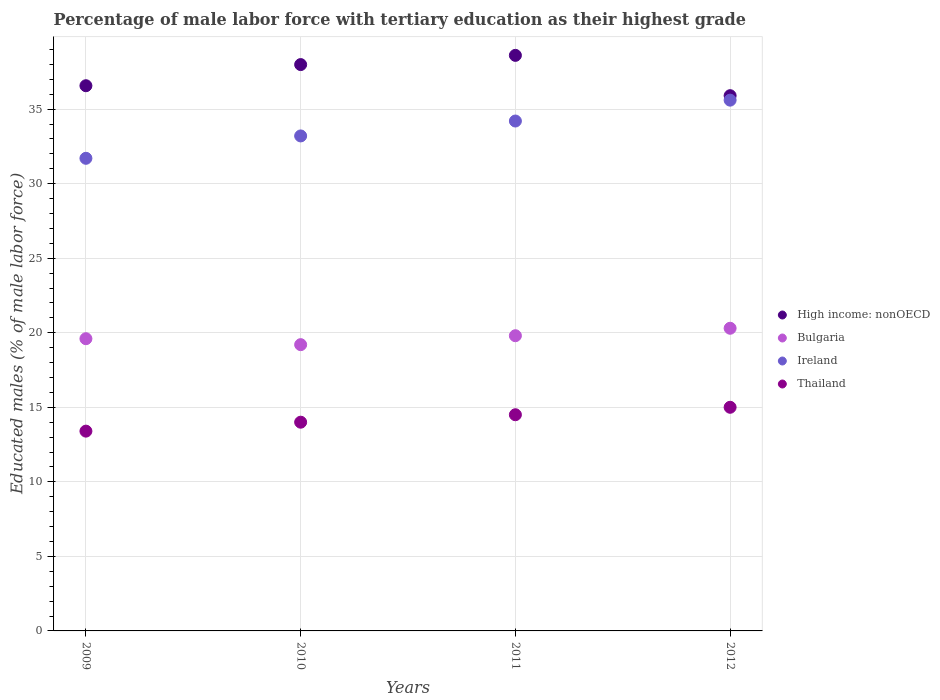How many different coloured dotlines are there?
Provide a short and direct response. 4. What is the percentage of male labor force with tertiary education in High income: nonOECD in 2011?
Make the answer very short. 38.6. Across all years, what is the minimum percentage of male labor force with tertiary education in Thailand?
Your answer should be very brief. 13.4. In which year was the percentage of male labor force with tertiary education in Bulgaria maximum?
Make the answer very short. 2012. What is the total percentage of male labor force with tertiary education in High income: nonOECD in the graph?
Your answer should be very brief. 149.06. What is the difference between the percentage of male labor force with tertiary education in Thailand in 2011 and that in 2012?
Keep it short and to the point. -0.5. What is the difference between the percentage of male labor force with tertiary education in Bulgaria in 2011 and the percentage of male labor force with tertiary education in Ireland in 2010?
Offer a terse response. -13.4. What is the average percentage of male labor force with tertiary education in Thailand per year?
Your answer should be very brief. 14.22. In the year 2009, what is the difference between the percentage of male labor force with tertiary education in High income: nonOECD and percentage of male labor force with tertiary education in Ireland?
Offer a terse response. 4.87. What is the ratio of the percentage of male labor force with tertiary education in Thailand in 2009 to that in 2011?
Provide a succinct answer. 0.92. What is the difference between the highest and the second highest percentage of male labor force with tertiary education in High income: nonOECD?
Offer a very short reply. 0.62. What is the difference between the highest and the lowest percentage of male labor force with tertiary education in Bulgaria?
Provide a short and direct response. 1.1. In how many years, is the percentage of male labor force with tertiary education in High income: nonOECD greater than the average percentage of male labor force with tertiary education in High income: nonOECD taken over all years?
Make the answer very short. 2. Is it the case that in every year, the sum of the percentage of male labor force with tertiary education in Bulgaria and percentage of male labor force with tertiary education in Ireland  is greater than the sum of percentage of male labor force with tertiary education in High income: nonOECD and percentage of male labor force with tertiary education in Thailand?
Provide a short and direct response. No. Is it the case that in every year, the sum of the percentage of male labor force with tertiary education in Bulgaria and percentage of male labor force with tertiary education in Ireland  is greater than the percentage of male labor force with tertiary education in High income: nonOECD?
Keep it short and to the point. Yes. Does the percentage of male labor force with tertiary education in High income: nonOECD monotonically increase over the years?
Your answer should be very brief. No. Is the percentage of male labor force with tertiary education in Thailand strictly greater than the percentage of male labor force with tertiary education in Bulgaria over the years?
Provide a succinct answer. No. Is the percentage of male labor force with tertiary education in High income: nonOECD strictly less than the percentage of male labor force with tertiary education in Thailand over the years?
Your answer should be very brief. No. How many dotlines are there?
Keep it short and to the point. 4. How many years are there in the graph?
Your answer should be very brief. 4. What is the difference between two consecutive major ticks on the Y-axis?
Your answer should be very brief. 5. Does the graph contain any zero values?
Provide a succinct answer. No. Does the graph contain grids?
Provide a short and direct response. Yes. Where does the legend appear in the graph?
Offer a terse response. Center right. How many legend labels are there?
Your answer should be very brief. 4. What is the title of the graph?
Give a very brief answer. Percentage of male labor force with tertiary education as their highest grade. What is the label or title of the X-axis?
Provide a succinct answer. Years. What is the label or title of the Y-axis?
Make the answer very short. Educated males (% of male labor force). What is the Educated males (% of male labor force) of High income: nonOECD in 2009?
Your response must be concise. 36.57. What is the Educated males (% of male labor force) of Bulgaria in 2009?
Provide a succinct answer. 19.6. What is the Educated males (% of male labor force) in Ireland in 2009?
Your answer should be compact. 31.7. What is the Educated males (% of male labor force) in Thailand in 2009?
Provide a succinct answer. 13.4. What is the Educated males (% of male labor force) in High income: nonOECD in 2010?
Your response must be concise. 37.99. What is the Educated males (% of male labor force) of Bulgaria in 2010?
Keep it short and to the point. 19.2. What is the Educated males (% of male labor force) in Ireland in 2010?
Your response must be concise. 33.2. What is the Educated males (% of male labor force) in High income: nonOECD in 2011?
Give a very brief answer. 38.6. What is the Educated males (% of male labor force) in Bulgaria in 2011?
Offer a very short reply. 19.8. What is the Educated males (% of male labor force) of Ireland in 2011?
Provide a succinct answer. 34.2. What is the Educated males (% of male labor force) of High income: nonOECD in 2012?
Keep it short and to the point. 35.9. What is the Educated males (% of male labor force) in Bulgaria in 2012?
Offer a very short reply. 20.3. What is the Educated males (% of male labor force) of Ireland in 2012?
Your response must be concise. 35.6. What is the Educated males (% of male labor force) of Thailand in 2012?
Offer a very short reply. 15. Across all years, what is the maximum Educated males (% of male labor force) of High income: nonOECD?
Make the answer very short. 38.6. Across all years, what is the maximum Educated males (% of male labor force) in Bulgaria?
Your response must be concise. 20.3. Across all years, what is the maximum Educated males (% of male labor force) of Ireland?
Your answer should be very brief. 35.6. Across all years, what is the maximum Educated males (% of male labor force) of Thailand?
Keep it short and to the point. 15. Across all years, what is the minimum Educated males (% of male labor force) in High income: nonOECD?
Provide a short and direct response. 35.9. Across all years, what is the minimum Educated males (% of male labor force) of Bulgaria?
Provide a short and direct response. 19.2. Across all years, what is the minimum Educated males (% of male labor force) of Ireland?
Your response must be concise. 31.7. Across all years, what is the minimum Educated males (% of male labor force) of Thailand?
Provide a succinct answer. 13.4. What is the total Educated males (% of male labor force) of High income: nonOECD in the graph?
Provide a short and direct response. 149.06. What is the total Educated males (% of male labor force) of Bulgaria in the graph?
Ensure brevity in your answer.  78.9. What is the total Educated males (% of male labor force) of Ireland in the graph?
Provide a succinct answer. 134.7. What is the total Educated males (% of male labor force) in Thailand in the graph?
Offer a terse response. 56.9. What is the difference between the Educated males (% of male labor force) in High income: nonOECD in 2009 and that in 2010?
Offer a terse response. -1.42. What is the difference between the Educated males (% of male labor force) in High income: nonOECD in 2009 and that in 2011?
Your answer should be compact. -2.04. What is the difference between the Educated males (% of male labor force) in Bulgaria in 2009 and that in 2011?
Provide a succinct answer. -0.2. What is the difference between the Educated males (% of male labor force) in High income: nonOECD in 2009 and that in 2012?
Provide a succinct answer. 0.67. What is the difference between the Educated males (% of male labor force) in Thailand in 2009 and that in 2012?
Give a very brief answer. -1.6. What is the difference between the Educated males (% of male labor force) in High income: nonOECD in 2010 and that in 2011?
Offer a very short reply. -0.62. What is the difference between the Educated males (% of male labor force) of Bulgaria in 2010 and that in 2011?
Ensure brevity in your answer.  -0.6. What is the difference between the Educated males (% of male labor force) of Ireland in 2010 and that in 2011?
Offer a terse response. -1. What is the difference between the Educated males (% of male labor force) of High income: nonOECD in 2010 and that in 2012?
Your response must be concise. 2.09. What is the difference between the Educated males (% of male labor force) of Ireland in 2010 and that in 2012?
Make the answer very short. -2.4. What is the difference between the Educated males (% of male labor force) in High income: nonOECD in 2011 and that in 2012?
Ensure brevity in your answer.  2.7. What is the difference between the Educated males (% of male labor force) in Bulgaria in 2011 and that in 2012?
Make the answer very short. -0.5. What is the difference between the Educated males (% of male labor force) of Thailand in 2011 and that in 2012?
Your answer should be compact. -0.5. What is the difference between the Educated males (% of male labor force) in High income: nonOECD in 2009 and the Educated males (% of male labor force) in Bulgaria in 2010?
Give a very brief answer. 17.37. What is the difference between the Educated males (% of male labor force) of High income: nonOECD in 2009 and the Educated males (% of male labor force) of Ireland in 2010?
Provide a short and direct response. 3.37. What is the difference between the Educated males (% of male labor force) of High income: nonOECD in 2009 and the Educated males (% of male labor force) of Thailand in 2010?
Keep it short and to the point. 22.57. What is the difference between the Educated males (% of male labor force) of Bulgaria in 2009 and the Educated males (% of male labor force) of Ireland in 2010?
Your answer should be very brief. -13.6. What is the difference between the Educated males (% of male labor force) in Bulgaria in 2009 and the Educated males (% of male labor force) in Thailand in 2010?
Provide a short and direct response. 5.6. What is the difference between the Educated males (% of male labor force) in Ireland in 2009 and the Educated males (% of male labor force) in Thailand in 2010?
Make the answer very short. 17.7. What is the difference between the Educated males (% of male labor force) in High income: nonOECD in 2009 and the Educated males (% of male labor force) in Bulgaria in 2011?
Give a very brief answer. 16.77. What is the difference between the Educated males (% of male labor force) in High income: nonOECD in 2009 and the Educated males (% of male labor force) in Ireland in 2011?
Your response must be concise. 2.37. What is the difference between the Educated males (% of male labor force) in High income: nonOECD in 2009 and the Educated males (% of male labor force) in Thailand in 2011?
Make the answer very short. 22.07. What is the difference between the Educated males (% of male labor force) of Bulgaria in 2009 and the Educated males (% of male labor force) of Ireland in 2011?
Give a very brief answer. -14.6. What is the difference between the Educated males (% of male labor force) in Bulgaria in 2009 and the Educated males (% of male labor force) in Thailand in 2011?
Your response must be concise. 5.1. What is the difference between the Educated males (% of male labor force) in Ireland in 2009 and the Educated males (% of male labor force) in Thailand in 2011?
Your response must be concise. 17.2. What is the difference between the Educated males (% of male labor force) in High income: nonOECD in 2009 and the Educated males (% of male labor force) in Bulgaria in 2012?
Offer a terse response. 16.27. What is the difference between the Educated males (% of male labor force) in High income: nonOECD in 2009 and the Educated males (% of male labor force) in Ireland in 2012?
Your response must be concise. 0.97. What is the difference between the Educated males (% of male labor force) in High income: nonOECD in 2009 and the Educated males (% of male labor force) in Thailand in 2012?
Offer a very short reply. 21.57. What is the difference between the Educated males (% of male labor force) of Ireland in 2009 and the Educated males (% of male labor force) of Thailand in 2012?
Provide a succinct answer. 16.7. What is the difference between the Educated males (% of male labor force) of High income: nonOECD in 2010 and the Educated males (% of male labor force) of Bulgaria in 2011?
Your answer should be compact. 18.19. What is the difference between the Educated males (% of male labor force) of High income: nonOECD in 2010 and the Educated males (% of male labor force) of Ireland in 2011?
Make the answer very short. 3.79. What is the difference between the Educated males (% of male labor force) of High income: nonOECD in 2010 and the Educated males (% of male labor force) of Thailand in 2011?
Ensure brevity in your answer.  23.49. What is the difference between the Educated males (% of male labor force) of Bulgaria in 2010 and the Educated males (% of male labor force) of Ireland in 2011?
Keep it short and to the point. -15. What is the difference between the Educated males (% of male labor force) of Ireland in 2010 and the Educated males (% of male labor force) of Thailand in 2011?
Keep it short and to the point. 18.7. What is the difference between the Educated males (% of male labor force) of High income: nonOECD in 2010 and the Educated males (% of male labor force) of Bulgaria in 2012?
Provide a short and direct response. 17.69. What is the difference between the Educated males (% of male labor force) in High income: nonOECD in 2010 and the Educated males (% of male labor force) in Ireland in 2012?
Ensure brevity in your answer.  2.39. What is the difference between the Educated males (% of male labor force) of High income: nonOECD in 2010 and the Educated males (% of male labor force) of Thailand in 2012?
Provide a succinct answer. 22.99. What is the difference between the Educated males (% of male labor force) in Bulgaria in 2010 and the Educated males (% of male labor force) in Ireland in 2012?
Your response must be concise. -16.4. What is the difference between the Educated males (% of male labor force) of High income: nonOECD in 2011 and the Educated males (% of male labor force) of Bulgaria in 2012?
Your answer should be very brief. 18.3. What is the difference between the Educated males (% of male labor force) of High income: nonOECD in 2011 and the Educated males (% of male labor force) of Ireland in 2012?
Give a very brief answer. 3. What is the difference between the Educated males (% of male labor force) in High income: nonOECD in 2011 and the Educated males (% of male labor force) in Thailand in 2012?
Offer a very short reply. 23.6. What is the difference between the Educated males (% of male labor force) in Bulgaria in 2011 and the Educated males (% of male labor force) in Ireland in 2012?
Keep it short and to the point. -15.8. What is the difference between the Educated males (% of male labor force) of Ireland in 2011 and the Educated males (% of male labor force) of Thailand in 2012?
Your answer should be compact. 19.2. What is the average Educated males (% of male labor force) of High income: nonOECD per year?
Provide a short and direct response. 37.26. What is the average Educated males (% of male labor force) in Bulgaria per year?
Keep it short and to the point. 19.73. What is the average Educated males (% of male labor force) of Ireland per year?
Provide a short and direct response. 33.67. What is the average Educated males (% of male labor force) of Thailand per year?
Offer a very short reply. 14.22. In the year 2009, what is the difference between the Educated males (% of male labor force) in High income: nonOECD and Educated males (% of male labor force) in Bulgaria?
Keep it short and to the point. 16.97. In the year 2009, what is the difference between the Educated males (% of male labor force) in High income: nonOECD and Educated males (% of male labor force) in Ireland?
Offer a terse response. 4.87. In the year 2009, what is the difference between the Educated males (% of male labor force) in High income: nonOECD and Educated males (% of male labor force) in Thailand?
Give a very brief answer. 23.17. In the year 2009, what is the difference between the Educated males (% of male labor force) in Bulgaria and Educated males (% of male labor force) in Ireland?
Give a very brief answer. -12.1. In the year 2009, what is the difference between the Educated males (% of male labor force) of Ireland and Educated males (% of male labor force) of Thailand?
Make the answer very short. 18.3. In the year 2010, what is the difference between the Educated males (% of male labor force) of High income: nonOECD and Educated males (% of male labor force) of Bulgaria?
Your answer should be very brief. 18.79. In the year 2010, what is the difference between the Educated males (% of male labor force) of High income: nonOECD and Educated males (% of male labor force) of Ireland?
Provide a succinct answer. 4.79. In the year 2010, what is the difference between the Educated males (% of male labor force) in High income: nonOECD and Educated males (% of male labor force) in Thailand?
Your answer should be compact. 23.99. In the year 2010, what is the difference between the Educated males (% of male labor force) of Bulgaria and Educated males (% of male labor force) of Ireland?
Make the answer very short. -14. In the year 2011, what is the difference between the Educated males (% of male labor force) in High income: nonOECD and Educated males (% of male labor force) in Bulgaria?
Ensure brevity in your answer.  18.8. In the year 2011, what is the difference between the Educated males (% of male labor force) in High income: nonOECD and Educated males (% of male labor force) in Ireland?
Offer a very short reply. 4.4. In the year 2011, what is the difference between the Educated males (% of male labor force) of High income: nonOECD and Educated males (% of male labor force) of Thailand?
Keep it short and to the point. 24.1. In the year 2011, what is the difference between the Educated males (% of male labor force) of Bulgaria and Educated males (% of male labor force) of Ireland?
Give a very brief answer. -14.4. In the year 2011, what is the difference between the Educated males (% of male labor force) of Bulgaria and Educated males (% of male labor force) of Thailand?
Ensure brevity in your answer.  5.3. In the year 2012, what is the difference between the Educated males (% of male labor force) of High income: nonOECD and Educated males (% of male labor force) of Bulgaria?
Your answer should be compact. 15.6. In the year 2012, what is the difference between the Educated males (% of male labor force) of High income: nonOECD and Educated males (% of male labor force) of Ireland?
Provide a succinct answer. 0.3. In the year 2012, what is the difference between the Educated males (% of male labor force) in High income: nonOECD and Educated males (% of male labor force) in Thailand?
Your answer should be compact. 20.9. In the year 2012, what is the difference between the Educated males (% of male labor force) in Bulgaria and Educated males (% of male labor force) in Ireland?
Keep it short and to the point. -15.3. In the year 2012, what is the difference between the Educated males (% of male labor force) of Ireland and Educated males (% of male labor force) of Thailand?
Provide a succinct answer. 20.6. What is the ratio of the Educated males (% of male labor force) in High income: nonOECD in 2009 to that in 2010?
Ensure brevity in your answer.  0.96. What is the ratio of the Educated males (% of male labor force) in Bulgaria in 2009 to that in 2010?
Give a very brief answer. 1.02. What is the ratio of the Educated males (% of male labor force) of Ireland in 2009 to that in 2010?
Make the answer very short. 0.95. What is the ratio of the Educated males (% of male labor force) of Thailand in 2009 to that in 2010?
Your answer should be compact. 0.96. What is the ratio of the Educated males (% of male labor force) of High income: nonOECD in 2009 to that in 2011?
Keep it short and to the point. 0.95. What is the ratio of the Educated males (% of male labor force) of Bulgaria in 2009 to that in 2011?
Keep it short and to the point. 0.99. What is the ratio of the Educated males (% of male labor force) in Ireland in 2009 to that in 2011?
Your answer should be compact. 0.93. What is the ratio of the Educated males (% of male labor force) in Thailand in 2009 to that in 2011?
Provide a short and direct response. 0.92. What is the ratio of the Educated males (% of male labor force) in High income: nonOECD in 2009 to that in 2012?
Your answer should be compact. 1.02. What is the ratio of the Educated males (% of male labor force) in Bulgaria in 2009 to that in 2012?
Offer a very short reply. 0.97. What is the ratio of the Educated males (% of male labor force) in Ireland in 2009 to that in 2012?
Provide a succinct answer. 0.89. What is the ratio of the Educated males (% of male labor force) of Thailand in 2009 to that in 2012?
Ensure brevity in your answer.  0.89. What is the ratio of the Educated males (% of male labor force) of High income: nonOECD in 2010 to that in 2011?
Ensure brevity in your answer.  0.98. What is the ratio of the Educated males (% of male labor force) in Bulgaria in 2010 to that in 2011?
Offer a very short reply. 0.97. What is the ratio of the Educated males (% of male labor force) in Ireland in 2010 to that in 2011?
Your response must be concise. 0.97. What is the ratio of the Educated males (% of male labor force) in Thailand in 2010 to that in 2011?
Make the answer very short. 0.97. What is the ratio of the Educated males (% of male labor force) in High income: nonOECD in 2010 to that in 2012?
Provide a short and direct response. 1.06. What is the ratio of the Educated males (% of male labor force) in Bulgaria in 2010 to that in 2012?
Offer a very short reply. 0.95. What is the ratio of the Educated males (% of male labor force) of Ireland in 2010 to that in 2012?
Offer a very short reply. 0.93. What is the ratio of the Educated males (% of male labor force) of High income: nonOECD in 2011 to that in 2012?
Keep it short and to the point. 1.08. What is the ratio of the Educated males (% of male labor force) in Bulgaria in 2011 to that in 2012?
Your answer should be compact. 0.98. What is the ratio of the Educated males (% of male labor force) of Ireland in 2011 to that in 2012?
Provide a short and direct response. 0.96. What is the ratio of the Educated males (% of male labor force) of Thailand in 2011 to that in 2012?
Your response must be concise. 0.97. What is the difference between the highest and the second highest Educated males (% of male labor force) of High income: nonOECD?
Make the answer very short. 0.62. What is the difference between the highest and the second highest Educated males (% of male labor force) in Bulgaria?
Offer a very short reply. 0.5. What is the difference between the highest and the lowest Educated males (% of male labor force) in High income: nonOECD?
Give a very brief answer. 2.7. What is the difference between the highest and the lowest Educated males (% of male labor force) in Ireland?
Your response must be concise. 3.9. What is the difference between the highest and the lowest Educated males (% of male labor force) of Thailand?
Ensure brevity in your answer.  1.6. 